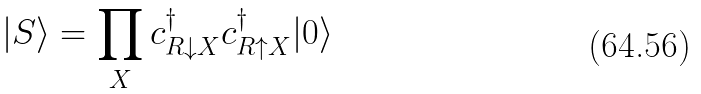Convert formula to latex. <formula><loc_0><loc_0><loc_500><loc_500>| { S } \rangle = \prod _ { X } c ^ { \dagger } _ { R \downarrow X } c ^ { \dagger } _ { R \uparrow X } | 0 \rangle</formula> 